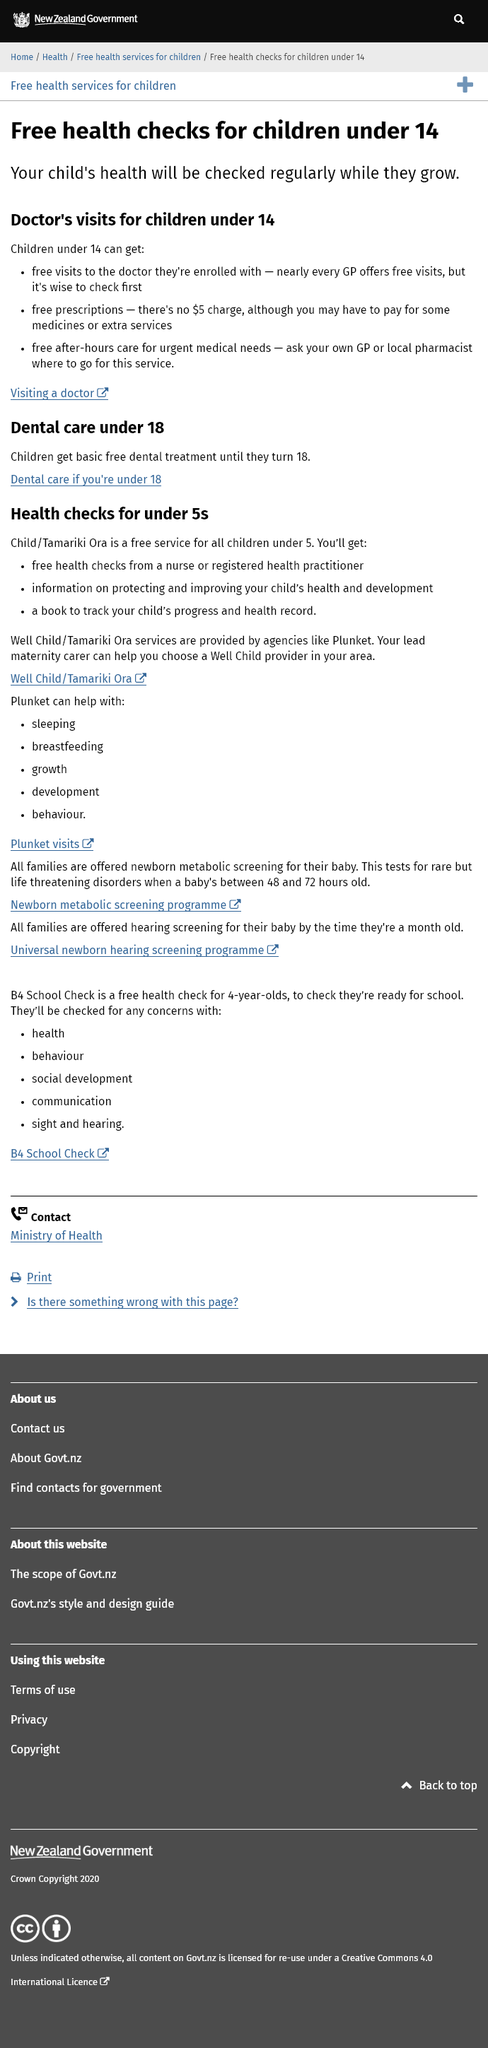Highlight a few significant elements in this photo. B4 School Check is a free health check for 4-year-old children, designed to assess their readiness for school and ensure their overall health and well-being. Well Child/Tamariki Ora Services are available free of charge, and are provided by agencies such as Plunket, which specialize in providing support and services for the health and well-being of children and their families. Yes, dental care and prescriptions are covered. After-hours care is included for urgent medical needs, and it is. According to the provided information, it is stated that children stop receiving free health checks at the age of 14. 